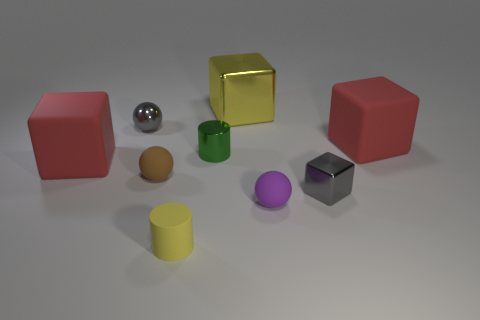Subtract 1 spheres. How many spheres are left? 2 Add 1 small shiny balls. How many objects exist? 10 Subtract all balls. How many objects are left? 6 Subtract 0 gray cylinders. How many objects are left? 9 Subtract all metal blocks. Subtract all tiny brown balls. How many objects are left? 6 Add 2 gray metal balls. How many gray metal balls are left? 3 Add 1 tiny green shiny things. How many tiny green shiny things exist? 2 